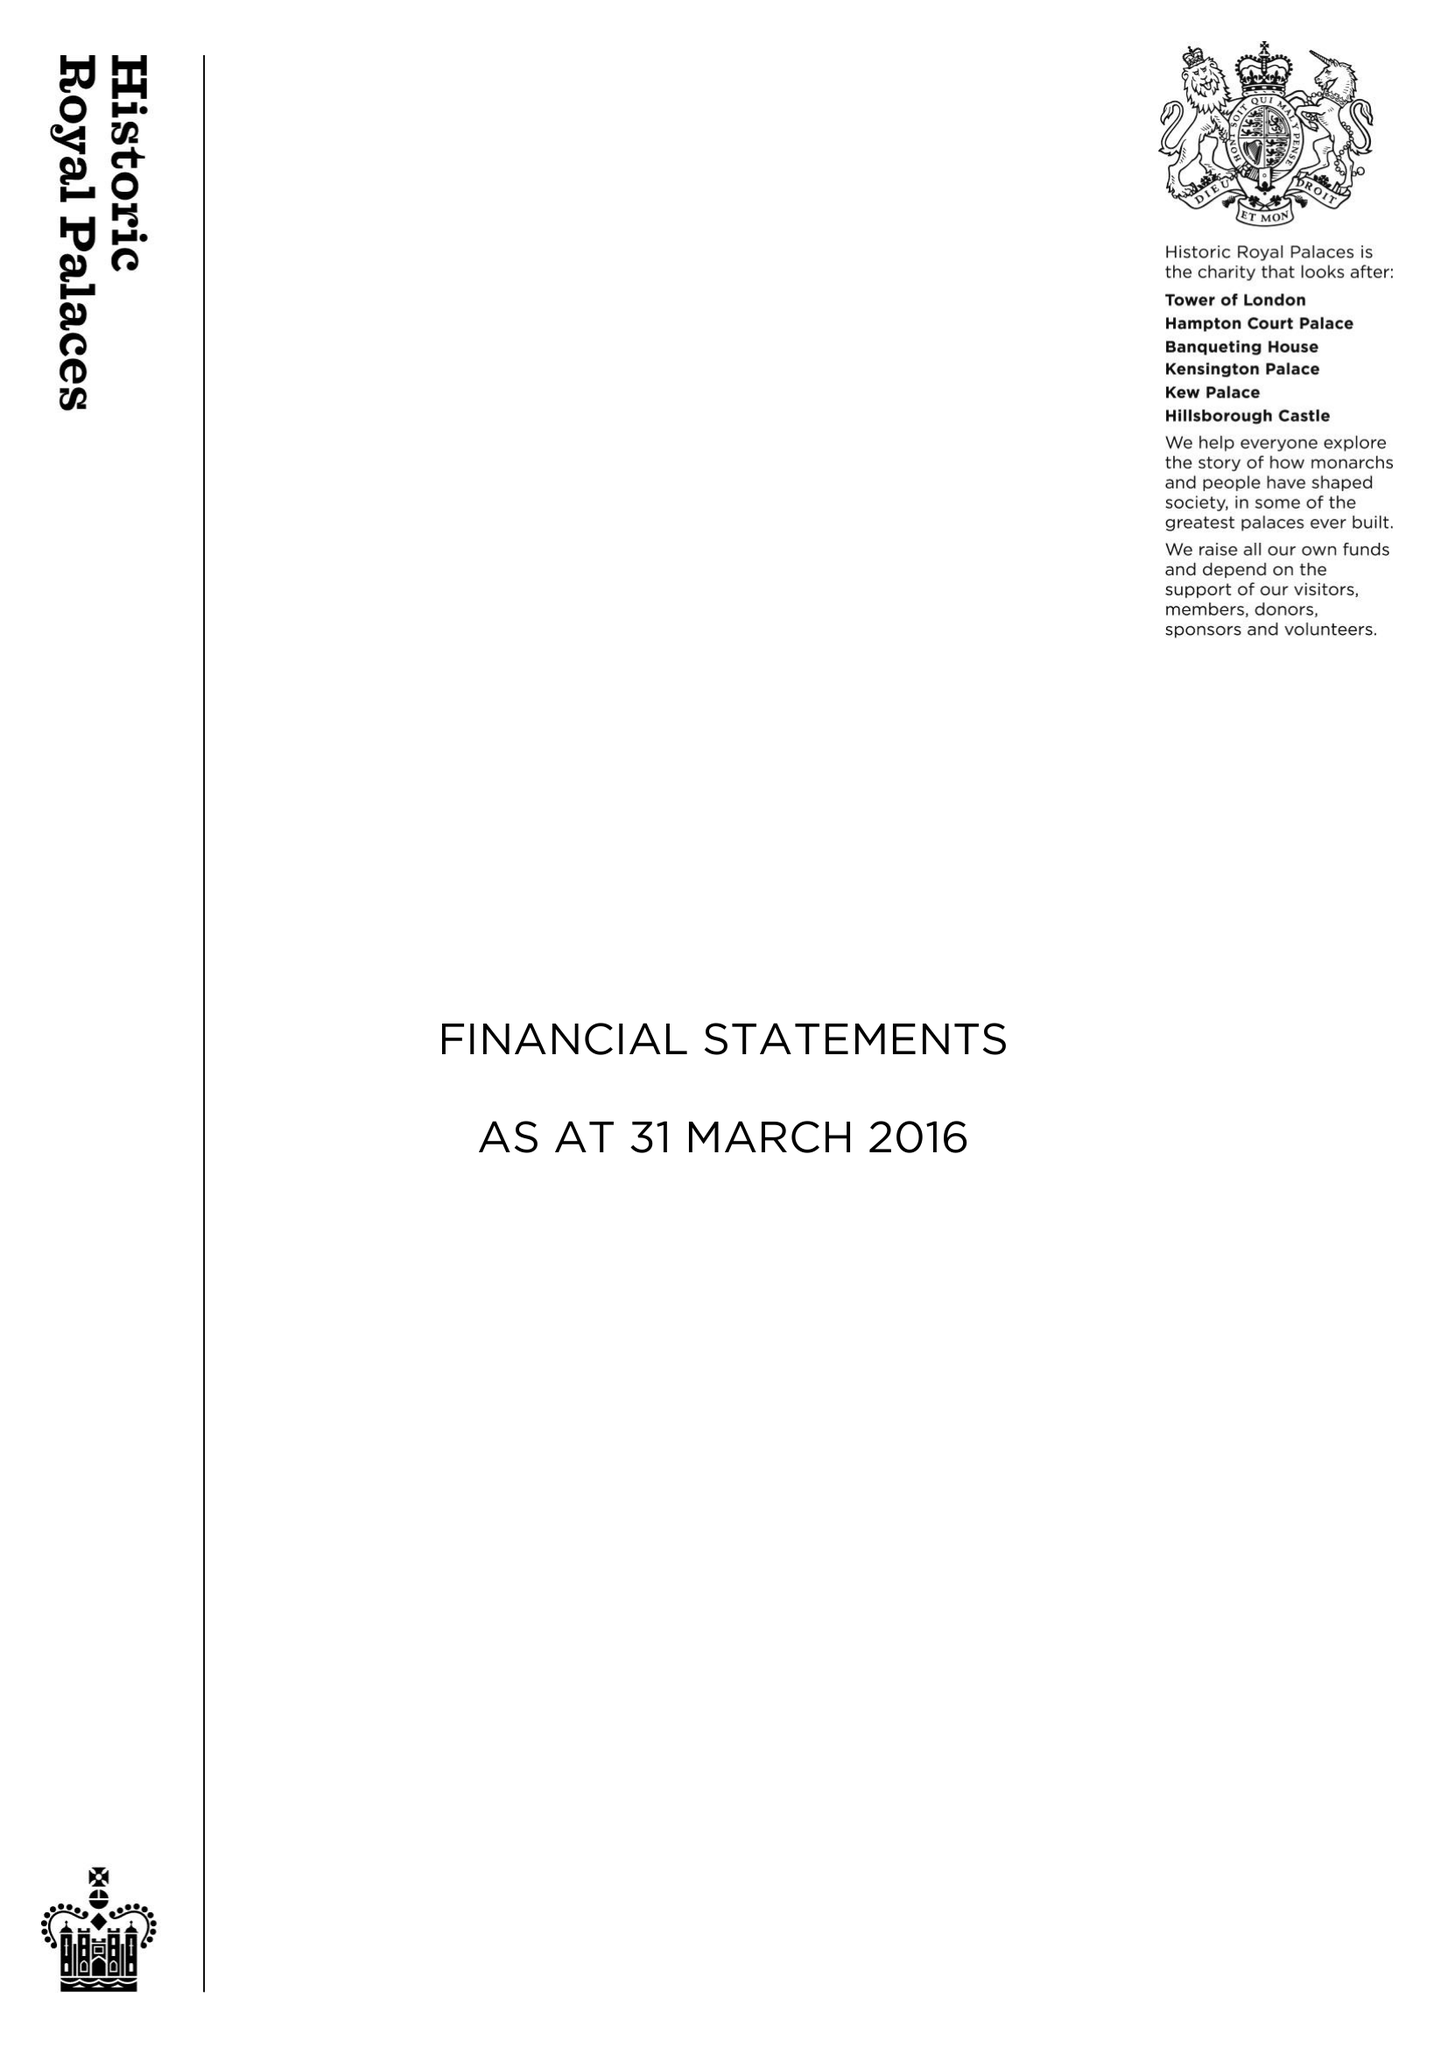What is the value for the address__postcode?
Answer the question using a single word or phrase. KT8 9AU 